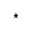<formula> <loc_0><loc_0><loc_500><loc_500>^ { * }</formula> 